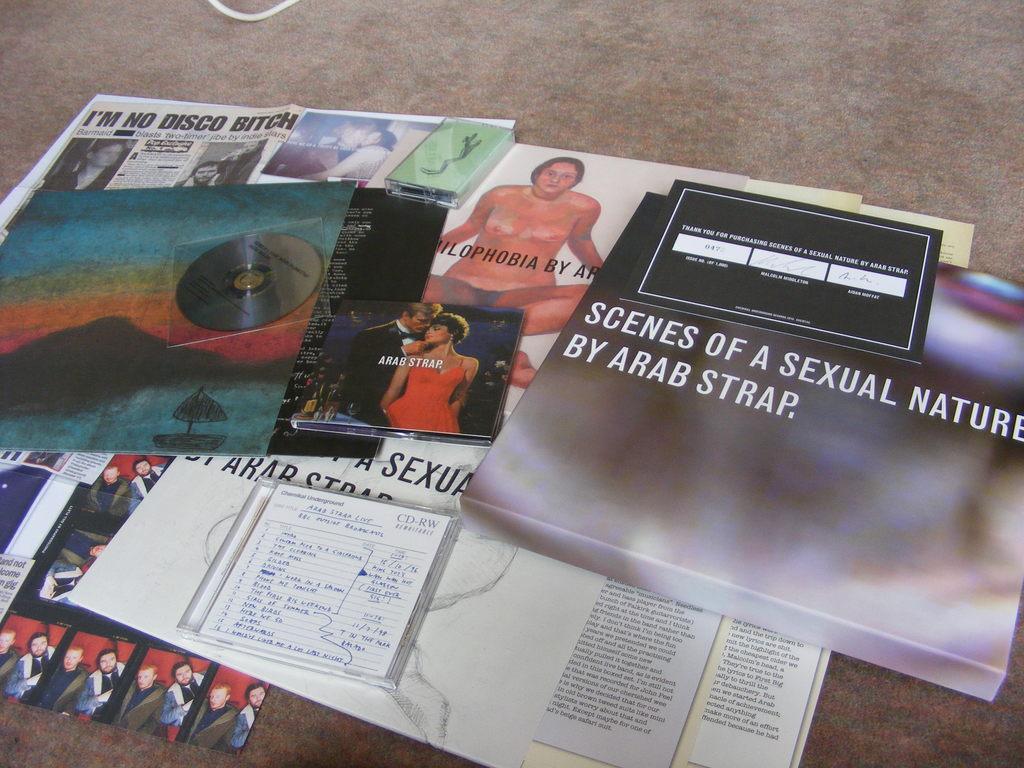In one or two sentences, can you explain what this image depicts? In this image I can see papers, there is a CD, book and there are some other objects on the floor. 